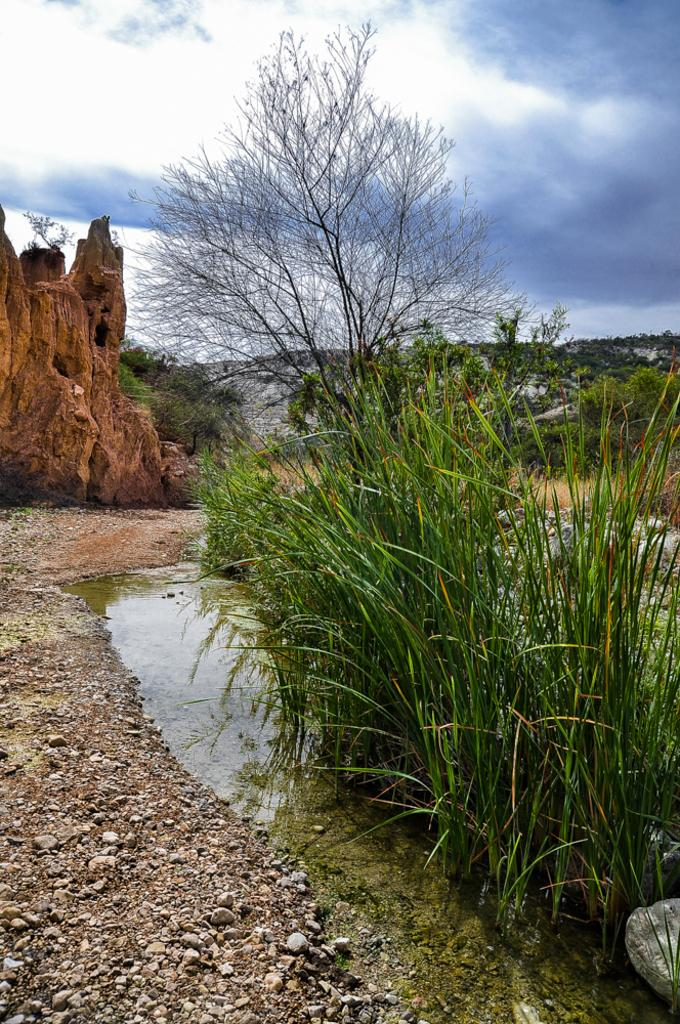What type of natural environment is depicted in the image? There is grass and water visible in the image, suggesting a natural environment. Can you describe any specific features of the landscape? There are stones at the left bottom of the image and a tree in the image. What is the condition of the sky in the image? The sky is cloudy at the top of the image. What type of horn can be heard during the carpenter's party in the image? There is no carpenter, party, or horn present in the image. 